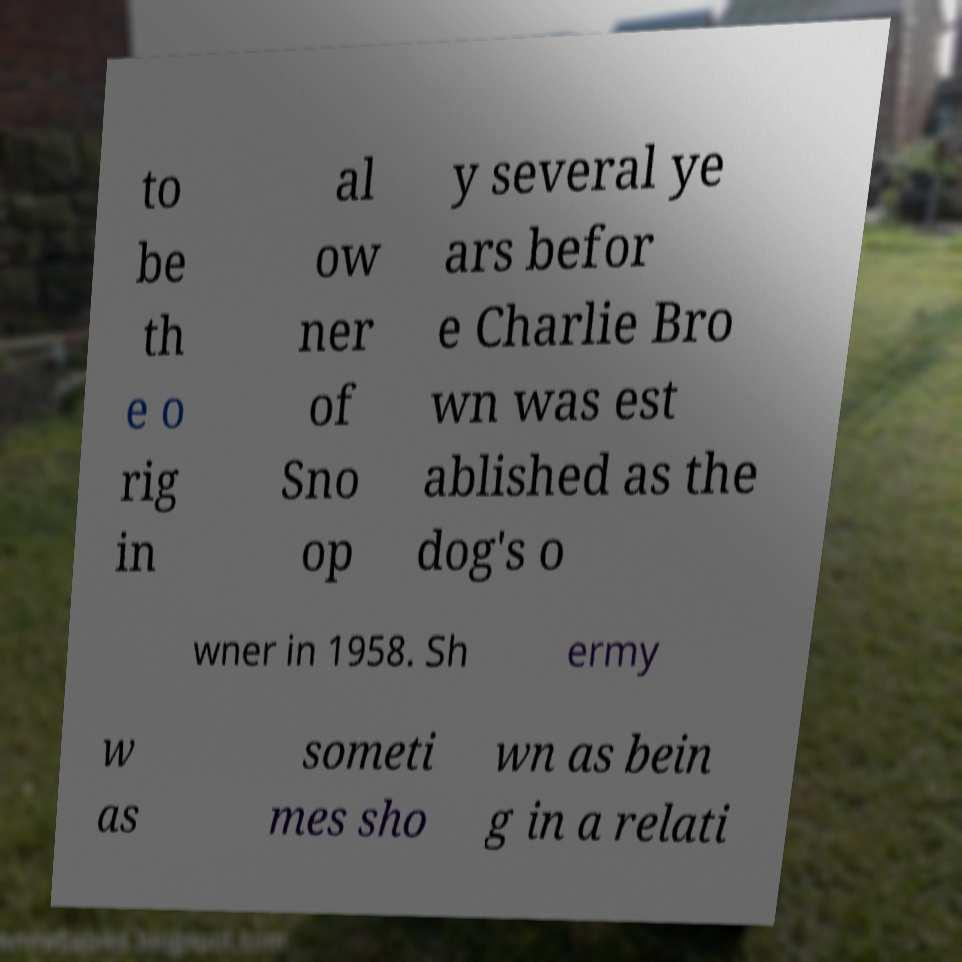Could you assist in decoding the text presented in this image and type it out clearly? to be th e o rig in al ow ner of Sno op y several ye ars befor e Charlie Bro wn was est ablished as the dog's o wner in 1958. Sh ermy w as someti mes sho wn as bein g in a relati 